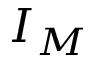<formula> <loc_0><loc_0><loc_500><loc_500>I _ { M }</formula> 